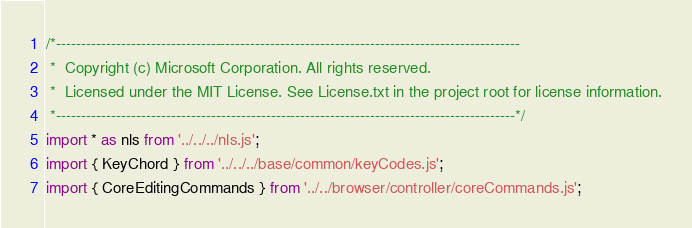Convert code to text. <code><loc_0><loc_0><loc_500><loc_500><_JavaScript_>/*---------------------------------------------------------------------------------------------
 *  Copyright (c) Microsoft Corporation. All rights reserved.
 *  Licensed under the MIT License. See License.txt in the project root for license information.
 *--------------------------------------------------------------------------------------------*/
import * as nls from '../../../nls.js';
import { KeyChord } from '../../../base/common/keyCodes.js';
import { CoreEditingCommands } from '../../browser/controller/coreCommands.js';</code> 